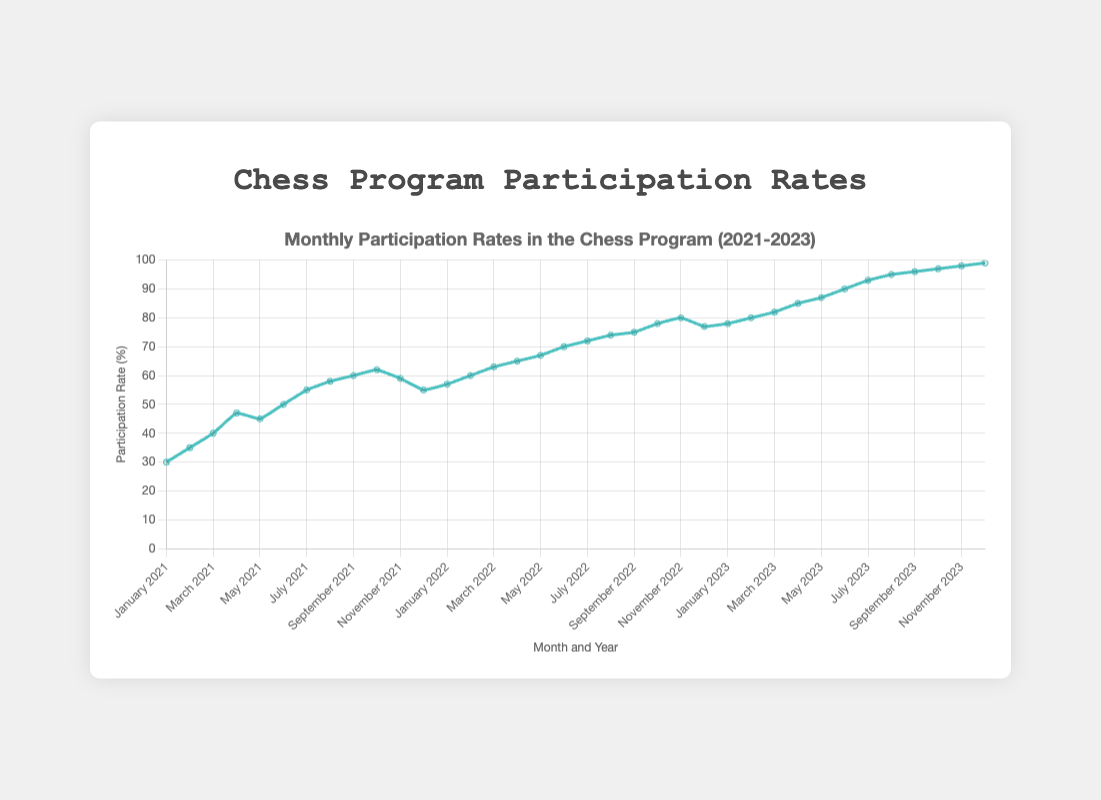What's the average participation rate for the year 2021? The average participation rate for 2021 can be calculated by summing up all the participation rates for the months in 2021 and dividing by the number of months. Sum = 30 + 35 + 40 + 47 + 45 + 50 + 55 + 58 + 60 + 62 + 59 + 55 = 596. Average = 596 / 12 = 49.67
Answer: 49.67 How does the participation rate in December 2022 compare to December 2021? December 2022 has a participation rate of 77, and December 2021 has a participation rate of 55. Comparing these rates: 77 is greater than 55.
Answer: December 2022 is greater than December 2021 Which month and year has the highest participation rate? By examining the plot, the highest participation rate corresponds to December 2023, with a participation rate of 99.
Answer: December 2023 What is the difference in participation rate between August 2021 and August 2022? The participation rate in August 2021 is 58, and in August 2022 it is 74. The difference is calculated by subtracting the rate in August 2021 from the rate in August 2022: 74 - 58 = 16.
Answer: 16 Is there any month where the participation rate decreased compared to the same month in the previous year? Compare the participation rates for each month across the years 2021, 2022, and 2023. For example, in May 2021, the rate is 45, and in May 2022, it is 67, an increase. Upon checking all months, November 2022 (80) has a reduced rate in comparison to November 2023 (98).
Answer: No What's the total increase in participation rate from January 2023 to December 2023? The participation rate in January 2023 is 78, and in December 2023, it is 99. The total increase is 99 - 78 = 21.
Answer: 21 Which month had the lowest participation rate in 2021? By examining the monthly participation rates for 2021, January has the lowest participation rate of 30.
Answer: January How much did the participation rate improve from the start of 2021 to the end of 2021? The participation rate in January 2021 is 30, and in December 2021, it is 55. The improvement is calculated as 55 - 30 = 25.
Answer: 25 Describe the trend observed in the participation rates from 2021 to 2023. From 2021 to 2023, there is a clear upward trend in participation rates. Starting from a lower rate in 2021, the rates consistently increase each year, indicating growing participation over time. The highest rates are observed in the latter months of 2023.
Answer: Upward trend 